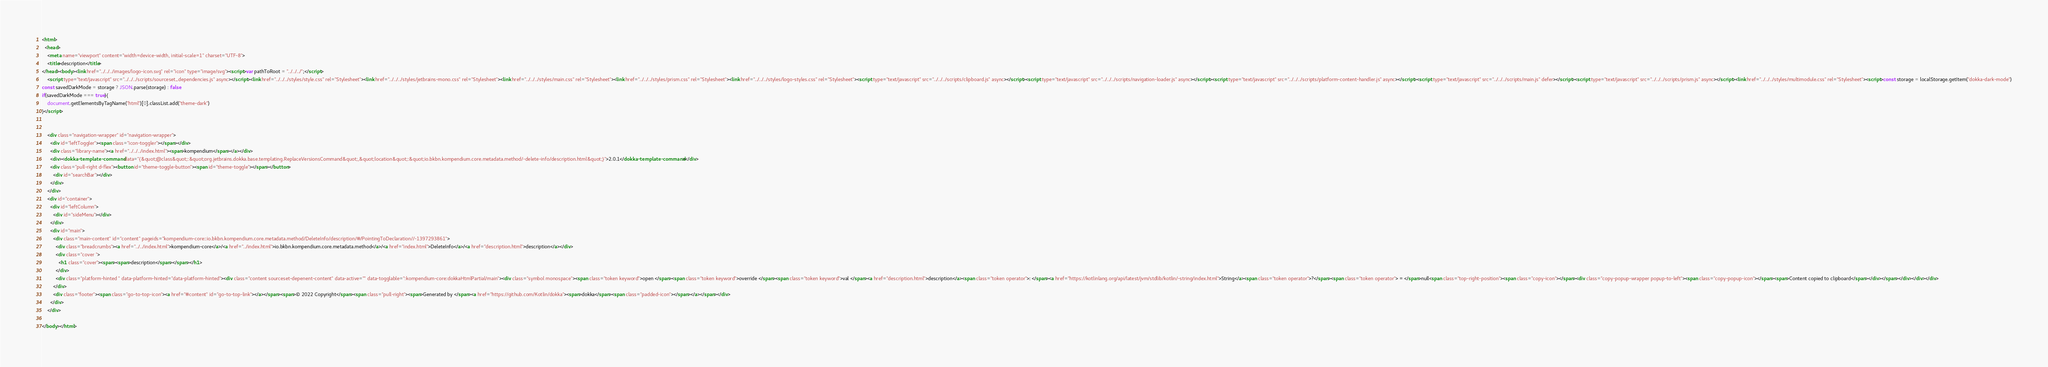Convert code to text. <code><loc_0><loc_0><loc_500><loc_500><_HTML_><html>
  <head>
    <meta name="viewport" content="width=device-width, initial-scale=1" charset="UTF-8">
    <title>description</title>
</head><body><link href="../../../images/logo-icon.svg" rel="icon" type="image/svg"><script>var pathToRoot = "../../../";</script>
    <script type="text/javascript" src="../../../scripts/sourceset_dependencies.js" async></script><link href="../../../styles/style.css" rel="Stylesheet"><link href="../../../styles/jetbrains-mono.css" rel="Stylesheet"><link href="../../../styles/main.css" rel="Stylesheet"><link href="../../../styles/prism.css" rel="Stylesheet"><link href="../../../styles/logo-styles.css" rel="Stylesheet"><script type="text/javascript" src="../../../scripts/clipboard.js" async></script><script type="text/javascript" src="../../../scripts/navigation-loader.js" async></script><script type="text/javascript" src="../../../scripts/platform-content-handler.js" async></script><script type="text/javascript" src="../../../scripts/main.js" defer></script><script type="text/javascript" src="../../../scripts/prism.js" async></script><link href="../../../styles/multimodule.css" rel="Stylesheet"><script>const storage = localStorage.getItem("dokka-dark-mode")
const savedDarkMode = storage ? JSON.parse(storage) : false
if(savedDarkMode === true){
    document.getElementsByTagName("html")[0].classList.add("theme-dark")
}</script>

  
    <div class="navigation-wrapper" id="navigation-wrapper">
      <div id="leftToggler"><span class="icon-toggler"></span></div>
      <div class="library-name"><a href="../../../index.html"><span>kompendium</span></a></div>
      <div><dokka-template-command data="{&quot;@class&quot;:&quot;org.jetbrains.dokka.base.templating.ReplaceVersionsCommand&quot;,&quot;location&quot;:&quot;io.bkbn.kompendium.core.metadata.method/-delete-info/description.html&quot;}">2.0.1</dokka-template-command></div>
      <div class="pull-right d-flex"><button id="theme-toggle-button"><span id="theme-toggle"></span></button>
        <div id="searchBar"></div>
      </div>
    </div>
    <div id="container">
      <div id="leftColumn">
        <div id="sideMenu"></div>
      </div>
      <div id="main">
        <div class="main-content" id="content" pageids="kompendium-core::io.bkbn.kompendium.core.metadata.method/DeleteInfo/description/#/PointingToDeclaration//-1397293861">
          <div class="breadcrumbs"><a href="../../index.html">kompendium-core</a>/<a href="../index.html">io.bkbn.kompendium.core.metadata.method</a>/<a href="index.html">DeleteInfo</a>/<a href="description.html">description</a></div>
          <div class="cover ">
            <h1 class="cover"><span><span>description</span></span></h1>
          </div>
          <div class="platform-hinted " data-platform-hinted="data-platform-hinted"><div class="content sourceset-depenent-content" data-active="" data-togglable=":kompendium-core:dokkaHtmlPartial/main"><div class="symbol monospace"><span class="token keyword">open </span><span class="token keyword">override </span><span class="token keyword">val </span><a href="description.html">description</a><span class="token operator">: </span><a href="https://kotlinlang.org/api/latest/jvm/stdlib/kotlin/-string/index.html">String</a><span class="token operator">?</span><span class="token operator"> = </span>null<span class="top-right-position"><span class="copy-icon"></span><div class="copy-popup-wrapper popup-to-left"><span class="copy-popup-icon"></span><span>Content copied to clipboard</span></div></span></div></div></div>
        </div>
        <div class="footer"><span class="go-to-top-icon"><a href="#content" id="go-to-top-link"></a></span><span>© 2022 Copyright</span><span class="pull-right"><span>Generated by </span><a href="https://github.com/Kotlin/dokka"><span>dokka</span><span class="padded-icon"></span></a></span></div>
      </div>
    </div>
  
</body></html>


</code> 